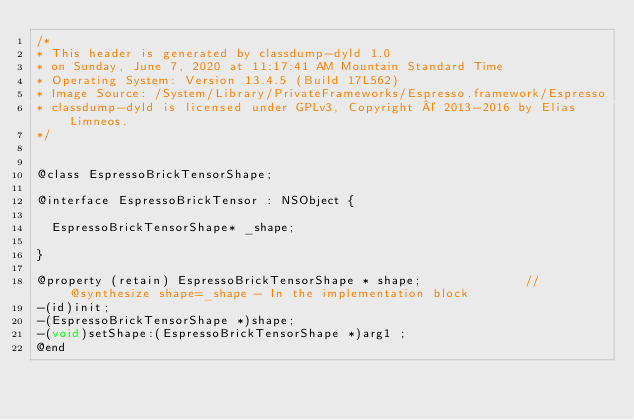<code> <loc_0><loc_0><loc_500><loc_500><_C_>/*
* This header is generated by classdump-dyld 1.0
* on Sunday, June 7, 2020 at 11:17:41 AM Mountain Standard Time
* Operating System: Version 13.4.5 (Build 17L562)
* Image Source: /System/Library/PrivateFrameworks/Espresso.framework/Espresso
* classdump-dyld is licensed under GPLv3, Copyright © 2013-2016 by Elias Limneos.
*/


@class EspressoBrickTensorShape;

@interface EspressoBrickTensor : NSObject {

	EspressoBrickTensorShape* _shape;

}

@property (retain) EspressoBrickTensorShape * shape;              //@synthesize shape=_shape - In the implementation block
-(id)init;
-(EspressoBrickTensorShape *)shape;
-(void)setShape:(EspressoBrickTensorShape *)arg1 ;
@end

</code> 